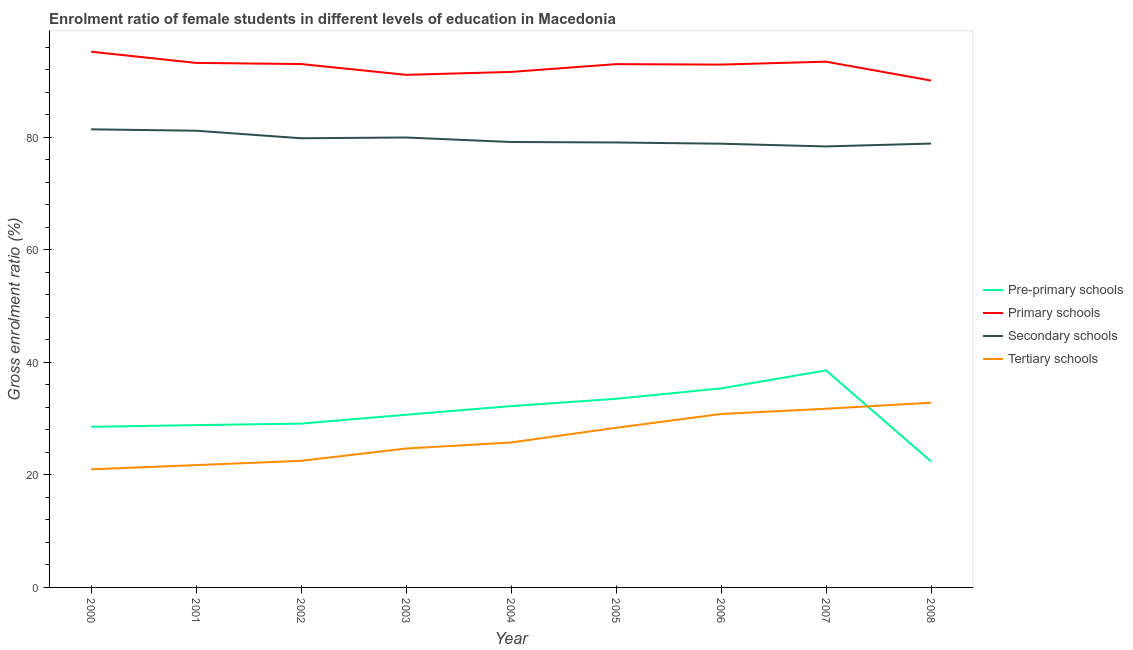How many different coloured lines are there?
Provide a succinct answer. 4. What is the gross enrolment ratio(male) in primary schools in 2003?
Provide a short and direct response. 91.11. Across all years, what is the maximum gross enrolment ratio(male) in pre-primary schools?
Keep it short and to the point. 38.58. Across all years, what is the minimum gross enrolment ratio(male) in primary schools?
Your answer should be very brief. 90.1. In which year was the gross enrolment ratio(male) in secondary schools maximum?
Provide a short and direct response. 2000. In which year was the gross enrolment ratio(male) in pre-primary schools minimum?
Make the answer very short. 2008. What is the total gross enrolment ratio(male) in primary schools in the graph?
Provide a short and direct response. 833.73. What is the difference between the gross enrolment ratio(male) in pre-primary schools in 2002 and that in 2004?
Ensure brevity in your answer.  -3.11. What is the difference between the gross enrolment ratio(male) in primary schools in 2002 and the gross enrolment ratio(male) in pre-primary schools in 2001?
Your response must be concise. 64.18. What is the average gross enrolment ratio(male) in primary schools per year?
Your answer should be very brief. 92.64. In the year 2001, what is the difference between the gross enrolment ratio(male) in tertiary schools and gross enrolment ratio(male) in pre-primary schools?
Ensure brevity in your answer.  -7.11. In how many years, is the gross enrolment ratio(male) in tertiary schools greater than 72 %?
Keep it short and to the point. 0. What is the ratio of the gross enrolment ratio(male) in secondary schools in 2000 to that in 2006?
Your response must be concise. 1.03. Is the gross enrolment ratio(male) in secondary schools in 2002 less than that in 2006?
Make the answer very short. No. What is the difference between the highest and the second highest gross enrolment ratio(male) in pre-primary schools?
Offer a very short reply. 3.2. What is the difference between the highest and the lowest gross enrolment ratio(male) in tertiary schools?
Your response must be concise. 11.84. In how many years, is the gross enrolment ratio(male) in tertiary schools greater than the average gross enrolment ratio(male) in tertiary schools taken over all years?
Your response must be concise. 4. Is the sum of the gross enrolment ratio(male) in pre-primary schools in 2001 and 2008 greater than the maximum gross enrolment ratio(male) in tertiary schools across all years?
Give a very brief answer. Yes. Is it the case that in every year, the sum of the gross enrolment ratio(male) in secondary schools and gross enrolment ratio(male) in pre-primary schools is greater than the sum of gross enrolment ratio(male) in tertiary schools and gross enrolment ratio(male) in primary schools?
Your answer should be very brief. Yes. Is it the case that in every year, the sum of the gross enrolment ratio(male) in pre-primary schools and gross enrolment ratio(male) in primary schools is greater than the gross enrolment ratio(male) in secondary schools?
Offer a very short reply. Yes. Is the gross enrolment ratio(male) in tertiary schools strictly greater than the gross enrolment ratio(male) in primary schools over the years?
Your answer should be compact. No. Is the gross enrolment ratio(male) in tertiary schools strictly less than the gross enrolment ratio(male) in pre-primary schools over the years?
Give a very brief answer. No. How many lines are there?
Your answer should be very brief. 4. How many years are there in the graph?
Provide a succinct answer. 9. How are the legend labels stacked?
Your answer should be compact. Vertical. What is the title of the graph?
Offer a very short reply. Enrolment ratio of female students in different levels of education in Macedonia. Does "Secondary" appear as one of the legend labels in the graph?
Give a very brief answer. No. What is the Gross enrolment ratio (%) in Pre-primary schools in 2000?
Give a very brief answer. 28.55. What is the Gross enrolment ratio (%) in Primary schools in 2000?
Your answer should be compact. 95.22. What is the Gross enrolment ratio (%) in Secondary schools in 2000?
Offer a very short reply. 81.43. What is the Gross enrolment ratio (%) of Tertiary schools in 2000?
Give a very brief answer. 21. What is the Gross enrolment ratio (%) of Pre-primary schools in 2001?
Give a very brief answer. 28.85. What is the Gross enrolment ratio (%) of Primary schools in 2001?
Offer a very short reply. 93.23. What is the Gross enrolment ratio (%) of Secondary schools in 2001?
Make the answer very short. 81.18. What is the Gross enrolment ratio (%) of Tertiary schools in 2001?
Keep it short and to the point. 21.74. What is the Gross enrolment ratio (%) of Pre-primary schools in 2002?
Give a very brief answer. 29.12. What is the Gross enrolment ratio (%) of Primary schools in 2002?
Offer a terse response. 93.03. What is the Gross enrolment ratio (%) of Secondary schools in 2002?
Provide a succinct answer. 79.84. What is the Gross enrolment ratio (%) of Tertiary schools in 2002?
Provide a succinct answer. 22.5. What is the Gross enrolment ratio (%) of Pre-primary schools in 2003?
Give a very brief answer. 30.7. What is the Gross enrolment ratio (%) of Primary schools in 2003?
Give a very brief answer. 91.11. What is the Gross enrolment ratio (%) in Secondary schools in 2003?
Ensure brevity in your answer.  79.97. What is the Gross enrolment ratio (%) of Tertiary schools in 2003?
Keep it short and to the point. 24.69. What is the Gross enrolment ratio (%) in Pre-primary schools in 2004?
Provide a short and direct response. 32.23. What is the Gross enrolment ratio (%) in Primary schools in 2004?
Offer a terse response. 91.63. What is the Gross enrolment ratio (%) in Secondary schools in 2004?
Make the answer very short. 79.17. What is the Gross enrolment ratio (%) of Tertiary schools in 2004?
Give a very brief answer. 25.76. What is the Gross enrolment ratio (%) in Pre-primary schools in 2005?
Keep it short and to the point. 33.53. What is the Gross enrolment ratio (%) of Primary schools in 2005?
Your response must be concise. 93.01. What is the Gross enrolment ratio (%) in Secondary schools in 2005?
Provide a short and direct response. 79.09. What is the Gross enrolment ratio (%) in Tertiary schools in 2005?
Keep it short and to the point. 28.38. What is the Gross enrolment ratio (%) of Pre-primary schools in 2006?
Your answer should be very brief. 35.38. What is the Gross enrolment ratio (%) of Primary schools in 2006?
Your answer should be compact. 92.93. What is the Gross enrolment ratio (%) of Secondary schools in 2006?
Ensure brevity in your answer.  78.87. What is the Gross enrolment ratio (%) in Tertiary schools in 2006?
Offer a terse response. 30.83. What is the Gross enrolment ratio (%) of Pre-primary schools in 2007?
Your response must be concise. 38.58. What is the Gross enrolment ratio (%) of Primary schools in 2007?
Offer a very short reply. 93.45. What is the Gross enrolment ratio (%) of Secondary schools in 2007?
Offer a terse response. 78.38. What is the Gross enrolment ratio (%) of Tertiary schools in 2007?
Provide a short and direct response. 31.76. What is the Gross enrolment ratio (%) of Pre-primary schools in 2008?
Give a very brief answer. 22.4. What is the Gross enrolment ratio (%) in Primary schools in 2008?
Ensure brevity in your answer.  90.1. What is the Gross enrolment ratio (%) in Secondary schools in 2008?
Your response must be concise. 78.9. What is the Gross enrolment ratio (%) in Tertiary schools in 2008?
Provide a short and direct response. 32.84. Across all years, what is the maximum Gross enrolment ratio (%) in Pre-primary schools?
Offer a very short reply. 38.58. Across all years, what is the maximum Gross enrolment ratio (%) in Primary schools?
Ensure brevity in your answer.  95.22. Across all years, what is the maximum Gross enrolment ratio (%) of Secondary schools?
Provide a succinct answer. 81.43. Across all years, what is the maximum Gross enrolment ratio (%) of Tertiary schools?
Your response must be concise. 32.84. Across all years, what is the minimum Gross enrolment ratio (%) of Pre-primary schools?
Provide a short and direct response. 22.4. Across all years, what is the minimum Gross enrolment ratio (%) of Primary schools?
Make the answer very short. 90.1. Across all years, what is the minimum Gross enrolment ratio (%) in Secondary schools?
Make the answer very short. 78.38. Across all years, what is the minimum Gross enrolment ratio (%) of Tertiary schools?
Your answer should be compact. 21. What is the total Gross enrolment ratio (%) of Pre-primary schools in the graph?
Your answer should be very brief. 279.34. What is the total Gross enrolment ratio (%) in Primary schools in the graph?
Provide a succinct answer. 833.73. What is the total Gross enrolment ratio (%) in Secondary schools in the graph?
Keep it short and to the point. 716.84. What is the total Gross enrolment ratio (%) in Tertiary schools in the graph?
Your answer should be very brief. 239.5. What is the difference between the Gross enrolment ratio (%) of Pre-primary schools in 2000 and that in 2001?
Your answer should be very brief. -0.3. What is the difference between the Gross enrolment ratio (%) in Primary schools in 2000 and that in 2001?
Provide a succinct answer. 1.99. What is the difference between the Gross enrolment ratio (%) in Secondary schools in 2000 and that in 2001?
Ensure brevity in your answer.  0.25. What is the difference between the Gross enrolment ratio (%) of Tertiary schools in 2000 and that in 2001?
Offer a terse response. -0.75. What is the difference between the Gross enrolment ratio (%) in Pre-primary schools in 2000 and that in 2002?
Offer a very short reply. -0.57. What is the difference between the Gross enrolment ratio (%) of Primary schools in 2000 and that in 2002?
Keep it short and to the point. 2.19. What is the difference between the Gross enrolment ratio (%) in Secondary schools in 2000 and that in 2002?
Ensure brevity in your answer.  1.59. What is the difference between the Gross enrolment ratio (%) of Tertiary schools in 2000 and that in 2002?
Offer a very short reply. -1.51. What is the difference between the Gross enrolment ratio (%) in Pre-primary schools in 2000 and that in 2003?
Keep it short and to the point. -2.15. What is the difference between the Gross enrolment ratio (%) of Primary schools in 2000 and that in 2003?
Offer a terse response. 4.11. What is the difference between the Gross enrolment ratio (%) of Secondary schools in 2000 and that in 2003?
Provide a succinct answer. 1.45. What is the difference between the Gross enrolment ratio (%) of Tertiary schools in 2000 and that in 2003?
Provide a short and direct response. -3.69. What is the difference between the Gross enrolment ratio (%) of Pre-primary schools in 2000 and that in 2004?
Offer a terse response. -3.68. What is the difference between the Gross enrolment ratio (%) of Primary schools in 2000 and that in 2004?
Provide a succinct answer. 3.59. What is the difference between the Gross enrolment ratio (%) in Secondary schools in 2000 and that in 2004?
Provide a succinct answer. 2.25. What is the difference between the Gross enrolment ratio (%) in Tertiary schools in 2000 and that in 2004?
Give a very brief answer. -4.76. What is the difference between the Gross enrolment ratio (%) in Pre-primary schools in 2000 and that in 2005?
Ensure brevity in your answer.  -4.98. What is the difference between the Gross enrolment ratio (%) of Primary schools in 2000 and that in 2005?
Your answer should be very brief. 2.21. What is the difference between the Gross enrolment ratio (%) in Secondary schools in 2000 and that in 2005?
Provide a short and direct response. 2.34. What is the difference between the Gross enrolment ratio (%) in Tertiary schools in 2000 and that in 2005?
Provide a succinct answer. -7.38. What is the difference between the Gross enrolment ratio (%) of Pre-primary schools in 2000 and that in 2006?
Provide a short and direct response. -6.83. What is the difference between the Gross enrolment ratio (%) of Primary schools in 2000 and that in 2006?
Ensure brevity in your answer.  2.29. What is the difference between the Gross enrolment ratio (%) in Secondary schools in 2000 and that in 2006?
Offer a terse response. 2.56. What is the difference between the Gross enrolment ratio (%) of Tertiary schools in 2000 and that in 2006?
Give a very brief answer. -9.83. What is the difference between the Gross enrolment ratio (%) in Pre-primary schools in 2000 and that in 2007?
Your response must be concise. -10.03. What is the difference between the Gross enrolment ratio (%) in Primary schools in 2000 and that in 2007?
Keep it short and to the point. 1.77. What is the difference between the Gross enrolment ratio (%) in Secondary schools in 2000 and that in 2007?
Provide a succinct answer. 3.04. What is the difference between the Gross enrolment ratio (%) in Tertiary schools in 2000 and that in 2007?
Your answer should be compact. -10.76. What is the difference between the Gross enrolment ratio (%) in Pre-primary schools in 2000 and that in 2008?
Give a very brief answer. 6.15. What is the difference between the Gross enrolment ratio (%) of Primary schools in 2000 and that in 2008?
Make the answer very short. 5.13. What is the difference between the Gross enrolment ratio (%) of Secondary schools in 2000 and that in 2008?
Offer a very short reply. 2.53. What is the difference between the Gross enrolment ratio (%) of Tertiary schools in 2000 and that in 2008?
Offer a very short reply. -11.84. What is the difference between the Gross enrolment ratio (%) in Pre-primary schools in 2001 and that in 2002?
Your answer should be compact. -0.27. What is the difference between the Gross enrolment ratio (%) of Primary schools in 2001 and that in 2002?
Offer a very short reply. 0.2. What is the difference between the Gross enrolment ratio (%) of Secondary schools in 2001 and that in 2002?
Provide a short and direct response. 1.34. What is the difference between the Gross enrolment ratio (%) in Tertiary schools in 2001 and that in 2002?
Your answer should be compact. -0.76. What is the difference between the Gross enrolment ratio (%) in Pre-primary schools in 2001 and that in 2003?
Offer a terse response. -1.84. What is the difference between the Gross enrolment ratio (%) of Primary schools in 2001 and that in 2003?
Your answer should be compact. 2.12. What is the difference between the Gross enrolment ratio (%) in Secondary schools in 2001 and that in 2003?
Your response must be concise. 1.21. What is the difference between the Gross enrolment ratio (%) in Tertiary schools in 2001 and that in 2003?
Keep it short and to the point. -2.95. What is the difference between the Gross enrolment ratio (%) of Pre-primary schools in 2001 and that in 2004?
Provide a succinct answer. -3.38. What is the difference between the Gross enrolment ratio (%) in Primary schools in 2001 and that in 2004?
Provide a succinct answer. 1.6. What is the difference between the Gross enrolment ratio (%) of Secondary schools in 2001 and that in 2004?
Make the answer very short. 2.01. What is the difference between the Gross enrolment ratio (%) of Tertiary schools in 2001 and that in 2004?
Make the answer very short. -4.02. What is the difference between the Gross enrolment ratio (%) in Pre-primary schools in 2001 and that in 2005?
Offer a terse response. -4.68. What is the difference between the Gross enrolment ratio (%) in Primary schools in 2001 and that in 2005?
Provide a short and direct response. 0.22. What is the difference between the Gross enrolment ratio (%) in Secondary schools in 2001 and that in 2005?
Your response must be concise. 2.09. What is the difference between the Gross enrolment ratio (%) in Tertiary schools in 2001 and that in 2005?
Offer a very short reply. -6.64. What is the difference between the Gross enrolment ratio (%) of Pre-primary schools in 2001 and that in 2006?
Your answer should be very brief. -6.53. What is the difference between the Gross enrolment ratio (%) of Primary schools in 2001 and that in 2006?
Offer a very short reply. 0.3. What is the difference between the Gross enrolment ratio (%) in Secondary schools in 2001 and that in 2006?
Make the answer very short. 2.31. What is the difference between the Gross enrolment ratio (%) in Tertiary schools in 2001 and that in 2006?
Your answer should be very brief. -9.09. What is the difference between the Gross enrolment ratio (%) in Pre-primary schools in 2001 and that in 2007?
Provide a succinct answer. -9.73. What is the difference between the Gross enrolment ratio (%) in Primary schools in 2001 and that in 2007?
Make the answer very short. -0.22. What is the difference between the Gross enrolment ratio (%) of Secondary schools in 2001 and that in 2007?
Offer a very short reply. 2.8. What is the difference between the Gross enrolment ratio (%) in Tertiary schools in 2001 and that in 2007?
Make the answer very short. -10.02. What is the difference between the Gross enrolment ratio (%) in Pre-primary schools in 2001 and that in 2008?
Keep it short and to the point. 6.45. What is the difference between the Gross enrolment ratio (%) of Primary schools in 2001 and that in 2008?
Provide a succinct answer. 3.14. What is the difference between the Gross enrolment ratio (%) of Secondary schools in 2001 and that in 2008?
Provide a short and direct response. 2.28. What is the difference between the Gross enrolment ratio (%) in Tertiary schools in 2001 and that in 2008?
Provide a short and direct response. -11.09. What is the difference between the Gross enrolment ratio (%) in Pre-primary schools in 2002 and that in 2003?
Ensure brevity in your answer.  -1.58. What is the difference between the Gross enrolment ratio (%) of Primary schools in 2002 and that in 2003?
Offer a terse response. 1.92. What is the difference between the Gross enrolment ratio (%) of Secondary schools in 2002 and that in 2003?
Make the answer very short. -0.13. What is the difference between the Gross enrolment ratio (%) of Tertiary schools in 2002 and that in 2003?
Ensure brevity in your answer.  -2.19. What is the difference between the Gross enrolment ratio (%) in Pre-primary schools in 2002 and that in 2004?
Your answer should be compact. -3.11. What is the difference between the Gross enrolment ratio (%) of Primary schools in 2002 and that in 2004?
Make the answer very short. 1.4. What is the difference between the Gross enrolment ratio (%) in Secondary schools in 2002 and that in 2004?
Make the answer very short. 0.67. What is the difference between the Gross enrolment ratio (%) of Tertiary schools in 2002 and that in 2004?
Ensure brevity in your answer.  -3.26. What is the difference between the Gross enrolment ratio (%) of Pre-primary schools in 2002 and that in 2005?
Your answer should be compact. -4.41. What is the difference between the Gross enrolment ratio (%) of Primary schools in 2002 and that in 2005?
Offer a very short reply. 0.02. What is the difference between the Gross enrolment ratio (%) in Secondary schools in 2002 and that in 2005?
Provide a short and direct response. 0.75. What is the difference between the Gross enrolment ratio (%) in Tertiary schools in 2002 and that in 2005?
Ensure brevity in your answer.  -5.88. What is the difference between the Gross enrolment ratio (%) in Pre-primary schools in 2002 and that in 2006?
Give a very brief answer. -6.26. What is the difference between the Gross enrolment ratio (%) in Primary schools in 2002 and that in 2006?
Keep it short and to the point. 0.1. What is the difference between the Gross enrolment ratio (%) of Secondary schools in 2002 and that in 2006?
Make the answer very short. 0.97. What is the difference between the Gross enrolment ratio (%) in Tertiary schools in 2002 and that in 2006?
Ensure brevity in your answer.  -8.33. What is the difference between the Gross enrolment ratio (%) in Pre-primary schools in 2002 and that in 2007?
Your answer should be compact. -9.46. What is the difference between the Gross enrolment ratio (%) of Primary schools in 2002 and that in 2007?
Offer a terse response. -0.42. What is the difference between the Gross enrolment ratio (%) in Secondary schools in 2002 and that in 2007?
Your response must be concise. 1.46. What is the difference between the Gross enrolment ratio (%) of Tertiary schools in 2002 and that in 2007?
Offer a terse response. -9.26. What is the difference between the Gross enrolment ratio (%) of Pre-primary schools in 2002 and that in 2008?
Offer a terse response. 6.72. What is the difference between the Gross enrolment ratio (%) in Primary schools in 2002 and that in 2008?
Give a very brief answer. 2.93. What is the difference between the Gross enrolment ratio (%) in Secondary schools in 2002 and that in 2008?
Ensure brevity in your answer.  0.94. What is the difference between the Gross enrolment ratio (%) in Tertiary schools in 2002 and that in 2008?
Your answer should be very brief. -10.33. What is the difference between the Gross enrolment ratio (%) of Pre-primary schools in 2003 and that in 2004?
Your response must be concise. -1.53. What is the difference between the Gross enrolment ratio (%) of Primary schools in 2003 and that in 2004?
Give a very brief answer. -0.52. What is the difference between the Gross enrolment ratio (%) in Secondary schools in 2003 and that in 2004?
Ensure brevity in your answer.  0.8. What is the difference between the Gross enrolment ratio (%) of Tertiary schools in 2003 and that in 2004?
Give a very brief answer. -1.07. What is the difference between the Gross enrolment ratio (%) of Pre-primary schools in 2003 and that in 2005?
Offer a very short reply. -2.83. What is the difference between the Gross enrolment ratio (%) of Primary schools in 2003 and that in 2005?
Your response must be concise. -1.9. What is the difference between the Gross enrolment ratio (%) of Secondary schools in 2003 and that in 2005?
Ensure brevity in your answer.  0.89. What is the difference between the Gross enrolment ratio (%) of Tertiary schools in 2003 and that in 2005?
Keep it short and to the point. -3.69. What is the difference between the Gross enrolment ratio (%) of Pre-primary schools in 2003 and that in 2006?
Ensure brevity in your answer.  -4.69. What is the difference between the Gross enrolment ratio (%) in Primary schools in 2003 and that in 2006?
Keep it short and to the point. -1.82. What is the difference between the Gross enrolment ratio (%) in Secondary schools in 2003 and that in 2006?
Provide a short and direct response. 1.1. What is the difference between the Gross enrolment ratio (%) of Tertiary schools in 2003 and that in 2006?
Offer a very short reply. -6.14. What is the difference between the Gross enrolment ratio (%) in Pre-primary schools in 2003 and that in 2007?
Give a very brief answer. -7.88. What is the difference between the Gross enrolment ratio (%) of Primary schools in 2003 and that in 2007?
Your answer should be very brief. -2.34. What is the difference between the Gross enrolment ratio (%) of Secondary schools in 2003 and that in 2007?
Provide a succinct answer. 1.59. What is the difference between the Gross enrolment ratio (%) in Tertiary schools in 2003 and that in 2007?
Keep it short and to the point. -7.07. What is the difference between the Gross enrolment ratio (%) in Pre-primary schools in 2003 and that in 2008?
Your answer should be compact. 8.29. What is the difference between the Gross enrolment ratio (%) of Primary schools in 2003 and that in 2008?
Make the answer very short. 1.02. What is the difference between the Gross enrolment ratio (%) of Secondary schools in 2003 and that in 2008?
Give a very brief answer. 1.08. What is the difference between the Gross enrolment ratio (%) in Tertiary schools in 2003 and that in 2008?
Provide a succinct answer. -8.15. What is the difference between the Gross enrolment ratio (%) in Pre-primary schools in 2004 and that in 2005?
Offer a very short reply. -1.3. What is the difference between the Gross enrolment ratio (%) in Primary schools in 2004 and that in 2005?
Your answer should be compact. -1.38. What is the difference between the Gross enrolment ratio (%) of Secondary schools in 2004 and that in 2005?
Offer a terse response. 0.08. What is the difference between the Gross enrolment ratio (%) in Tertiary schools in 2004 and that in 2005?
Provide a short and direct response. -2.62. What is the difference between the Gross enrolment ratio (%) in Pre-primary schools in 2004 and that in 2006?
Provide a succinct answer. -3.15. What is the difference between the Gross enrolment ratio (%) in Primary schools in 2004 and that in 2006?
Provide a succinct answer. -1.3. What is the difference between the Gross enrolment ratio (%) of Secondary schools in 2004 and that in 2006?
Your response must be concise. 0.3. What is the difference between the Gross enrolment ratio (%) in Tertiary schools in 2004 and that in 2006?
Provide a succinct answer. -5.07. What is the difference between the Gross enrolment ratio (%) in Pre-primary schools in 2004 and that in 2007?
Offer a terse response. -6.35. What is the difference between the Gross enrolment ratio (%) in Primary schools in 2004 and that in 2007?
Offer a very short reply. -1.82. What is the difference between the Gross enrolment ratio (%) of Secondary schools in 2004 and that in 2007?
Make the answer very short. 0.79. What is the difference between the Gross enrolment ratio (%) in Tertiary schools in 2004 and that in 2007?
Ensure brevity in your answer.  -6. What is the difference between the Gross enrolment ratio (%) of Pre-primary schools in 2004 and that in 2008?
Your answer should be very brief. 9.83. What is the difference between the Gross enrolment ratio (%) of Primary schools in 2004 and that in 2008?
Your answer should be compact. 1.53. What is the difference between the Gross enrolment ratio (%) in Secondary schools in 2004 and that in 2008?
Provide a short and direct response. 0.27. What is the difference between the Gross enrolment ratio (%) of Tertiary schools in 2004 and that in 2008?
Your response must be concise. -7.07. What is the difference between the Gross enrolment ratio (%) of Pre-primary schools in 2005 and that in 2006?
Offer a very short reply. -1.85. What is the difference between the Gross enrolment ratio (%) in Primary schools in 2005 and that in 2006?
Provide a short and direct response. 0.08. What is the difference between the Gross enrolment ratio (%) in Secondary schools in 2005 and that in 2006?
Your answer should be compact. 0.22. What is the difference between the Gross enrolment ratio (%) in Tertiary schools in 2005 and that in 2006?
Give a very brief answer. -2.45. What is the difference between the Gross enrolment ratio (%) of Pre-primary schools in 2005 and that in 2007?
Your answer should be very brief. -5.05. What is the difference between the Gross enrolment ratio (%) of Primary schools in 2005 and that in 2007?
Give a very brief answer. -0.44. What is the difference between the Gross enrolment ratio (%) of Secondary schools in 2005 and that in 2007?
Your answer should be very brief. 0.7. What is the difference between the Gross enrolment ratio (%) of Tertiary schools in 2005 and that in 2007?
Provide a short and direct response. -3.38. What is the difference between the Gross enrolment ratio (%) of Pre-primary schools in 2005 and that in 2008?
Keep it short and to the point. 11.13. What is the difference between the Gross enrolment ratio (%) in Primary schools in 2005 and that in 2008?
Provide a short and direct response. 2.92. What is the difference between the Gross enrolment ratio (%) of Secondary schools in 2005 and that in 2008?
Offer a terse response. 0.19. What is the difference between the Gross enrolment ratio (%) of Tertiary schools in 2005 and that in 2008?
Provide a succinct answer. -4.46. What is the difference between the Gross enrolment ratio (%) of Pre-primary schools in 2006 and that in 2007?
Give a very brief answer. -3.2. What is the difference between the Gross enrolment ratio (%) in Primary schools in 2006 and that in 2007?
Your response must be concise. -0.52. What is the difference between the Gross enrolment ratio (%) of Secondary schools in 2006 and that in 2007?
Your answer should be very brief. 0.48. What is the difference between the Gross enrolment ratio (%) in Tertiary schools in 2006 and that in 2007?
Ensure brevity in your answer.  -0.93. What is the difference between the Gross enrolment ratio (%) of Pre-primary schools in 2006 and that in 2008?
Your answer should be compact. 12.98. What is the difference between the Gross enrolment ratio (%) of Primary schools in 2006 and that in 2008?
Provide a succinct answer. 2.84. What is the difference between the Gross enrolment ratio (%) in Secondary schools in 2006 and that in 2008?
Give a very brief answer. -0.03. What is the difference between the Gross enrolment ratio (%) of Tertiary schools in 2006 and that in 2008?
Give a very brief answer. -2.01. What is the difference between the Gross enrolment ratio (%) in Pre-primary schools in 2007 and that in 2008?
Provide a succinct answer. 16.18. What is the difference between the Gross enrolment ratio (%) of Primary schools in 2007 and that in 2008?
Give a very brief answer. 3.36. What is the difference between the Gross enrolment ratio (%) in Secondary schools in 2007 and that in 2008?
Give a very brief answer. -0.51. What is the difference between the Gross enrolment ratio (%) of Tertiary schools in 2007 and that in 2008?
Ensure brevity in your answer.  -1.08. What is the difference between the Gross enrolment ratio (%) of Pre-primary schools in 2000 and the Gross enrolment ratio (%) of Primary schools in 2001?
Provide a short and direct response. -64.68. What is the difference between the Gross enrolment ratio (%) in Pre-primary schools in 2000 and the Gross enrolment ratio (%) in Secondary schools in 2001?
Give a very brief answer. -52.63. What is the difference between the Gross enrolment ratio (%) in Pre-primary schools in 2000 and the Gross enrolment ratio (%) in Tertiary schools in 2001?
Give a very brief answer. 6.81. What is the difference between the Gross enrolment ratio (%) of Primary schools in 2000 and the Gross enrolment ratio (%) of Secondary schools in 2001?
Make the answer very short. 14.04. What is the difference between the Gross enrolment ratio (%) in Primary schools in 2000 and the Gross enrolment ratio (%) in Tertiary schools in 2001?
Provide a short and direct response. 73.48. What is the difference between the Gross enrolment ratio (%) of Secondary schools in 2000 and the Gross enrolment ratio (%) of Tertiary schools in 2001?
Offer a terse response. 59.68. What is the difference between the Gross enrolment ratio (%) in Pre-primary schools in 2000 and the Gross enrolment ratio (%) in Primary schools in 2002?
Your answer should be very brief. -64.48. What is the difference between the Gross enrolment ratio (%) in Pre-primary schools in 2000 and the Gross enrolment ratio (%) in Secondary schools in 2002?
Ensure brevity in your answer.  -51.29. What is the difference between the Gross enrolment ratio (%) of Pre-primary schools in 2000 and the Gross enrolment ratio (%) of Tertiary schools in 2002?
Give a very brief answer. 6.05. What is the difference between the Gross enrolment ratio (%) of Primary schools in 2000 and the Gross enrolment ratio (%) of Secondary schools in 2002?
Make the answer very short. 15.38. What is the difference between the Gross enrolment ratio (%) in Primary schools in 2000 and the Gross enrolment ratio (%) in Tertiary schools in 2002?
Your answer should be compact. 72.72. What is the difference between the Gross enrolment ratio (%) of Secondary schools in 2000 and the Gross enrolment ratio (%) of Tertiary schools in 2002?
Your answer should be compact. 58.92. What is the difference between the Gross enrolment ratio (%) in Pre-primary schools in 2000 and the Gross enrolment ratio (%) in Primary schools in 2003?
Your answer should be very brief. -62.56. What is the difference between the Gross enrolment ratio (%) in Pre-primary schools in 2000 and the Gross enrolment ratio (%) in Secondary schools in 2003?
Keep it short and to the point. -51.42. What is the difference between the Gross enrolment ratio (%) in Pre-primary schools in 2000 and the Gross enrolment ratio (%) in Tertiary schools in 2003?
Provide a succinct answer. 3.86. What is the difference between the Gross enrolment ratio (%) of Primary schools in 2000 and the Gross enrolment ratio (%) of Secondary schools in 2003?
Provide a short and direct response. 15.25. What is the difference between the Gross enrolment ratio (%) of Primary schools in 2000 and the Gross enrolment ratio (%) of Tertiary schools in 2003?
Offer a terse response. 70.53. What is the difference between the Gross enrolment ratio (%) in Secondary schools in 2000 and the Gross enrolment ratio (%) in Tertiary schools in 2003?
Your response must be concise. 56.74. What is the difference between the Gross enrolment ratio (%) of Pre-primary schools in 2000 and the Gross enrolment ratio (%) of Primary schools in 2004?
Offer a terse response. -63.08. What is the difference between the Gross enrolment ratio (%) of Pre-primary schools in 2000 and the Gross enrolment ratio (%) of Secondary schools in 2004?
Your answer should be compact. -50.62. What is the difference between the Gross enrolment ratio (%) of Pre-primary schools in 2000 and the Gross enrolment ratio (%) of Tertiary schools in 2004?
Keep it short and to the point. 2.79. What is the difference between the Gross enrolment ratio (%) in Primary schools in 2000 and the Gross enrolment ratio (%) in Secondary schools in 2004?
Provide a short and direct response. 16.05. What is the difference between the Gross enrolment ratio (%) of Primary schools in 2000 and the Gross enrolment ratio (%) of Tertiary schools in 2004?
Make the answer very short. 69.46. What is the difference between the Gross enrolment ratio (%) of Secondary schools in 2000 and the Gross enrolment ratio (%) of Tertiary schools in 2004?
Your answer should be compact. 55.66. What is the difference between the Gross enrolment ratio (%) in Pre-primary schools in 2000 and the Gross enrolment ratio (%) in Primary schools in 2005?
Your answer should be very brief. -64.46. What is the difference between the Gross enrolment ratio (%) in Pre-primary schools in 2000 and the Gross enrolment ratio (%) in Secondary schools in 2005?
Provide a short and direct response. -50.54. What is the difference between the Gross enrolment ratio (%) of Pre-primary schools in 2000 and the Gross enrolment ratio (%) of Tertiary schools in 2005?
Provide a short and direct response. 0.17. What is the difference between the Gross enrolment ratio (%) in Primary schools in 2000 and the Gross enrolment ratio (%) in Secondary schools in 2005?
Ensure brevity in your answer.  16.13. What is the difference between the Gross enrolment ratio (%) of Primary schools in 2000 and the Gross enrolment ratio (%) of Tertiary schools in 2005?
Provide a short and direct response. 66.85. What is the difference between the Gross enrolment ratio (%) of Secondary schools in 2000 and the Gross enrolment ratio (%) of Tertiary schools in 2005?
Your answer should be very brief. 53.05. What is the difference between the Gross enrolment ratio (%) in Pre-primary schools in 2000 and the Gross enrolment ratio (%) in Primary schools in 2006?
Provide a short and direct response. -64.38. What is the difference between the Gross enrolment ratio (%) in Pre-primary schools in 2000 and the Gross enrolment ratio (%) in Secondary schools in 2006?
Your answer should be very brief. -50.32. What is the difference between the Gross enrolment ratio (%) of Pre-primary schools in 2000 and the Gross enrolment ratio (%) of Tertiary schools in 2006?
Make the answer very short. -2.28. What is the difference between the Gross enrolment ratio (%) in Primary schools in 2000 and the Gross enrolment ratio (%) in Secondary schools in 2006?
Keep it short and to the point. 16.35. What is the difference between the Gross enrolment ratio (%) in Primary schools in 2000 and the Gross enrolment ratio (%) in Tertiary schools in 2006?
Provide a succinct answer. 64.4. What is the difference between the Gross enrolment ratio (%) in Secondary schools in 2000 and the Gross enrolment ratio (%) in Tertiary schools in 2006?
Your answer should be very brief. 50.6. What is the difference between the Gross enrolment ratio (%) of Pre-primary schools in 2000 and the Gross enrolment ratio (%) of Primary schools in 2007?
Offer a very short reply. -64.9. What is the difference between the Gross enrolment ratio (%) in Pre-primary schools in 2000 and the Gross enrolment ratio (%) in Secondary schools in 2007?
Provide a succinct answer. -49.84. What is the difference between the Gross enrolment ratio (%) in Pre-primary schools in 2000 and the Gross enrolment ratio (%) in Tertiary schools in 2007?
Give a very brief answer. -3.21. What is the difference between the Gross enrolment ratio (%) of Primary schools in 2000 and the Gross enrolment ratio (%) of Secondary schools in 2007?
Offer a terse response. 16.84. What is the difference between the Gross enrolment ratio (%) in Primary schools in 2000 and the Gross enrolment ratio (%) in Tertiary schools in 2007?
Your response must be concise. 63.46. What is the difference between the Gross enrolment ratio (%) in Secondary schools in 2000 and the Gross enrolment ratio (%) in Tertiary schools in 2007?
Ensure brevity in your answer.  49.67. What is the difference between the Gross enrolment ratio (%) in Pre-primary schools in 2000 and the Gross enrolment ratio (%) in Primary schools in 2008?
Offer a terse response. -61.55. What is the difference between the Gross enrolment ratio (%) in Pre-primary schools in 2000 and the Gross enrolment ratio (%) in Secondary schools in 2008?
Offer a terse response. -50.35. What is the difference between the Gross enrolment ratio (%) of Pre-primary schools in 2000 and the Gross enrolment ratio (%) of Tertiary schools in 2008?
Ensure brevity in your answer.  -4.29. What is the difference between the Gross enrolment ratio (%) of Primary schools in 2000 and the Gross enrolment ratio (%) of Secondary schools in 2008?
Offer a terse response. 16.33. What is the difference between the Gross enrolment ratio (%) in Primary schools in 2000 and the Gross enrolment ratio (%) in Tertiary schools in 2008?
Make the answer very short. 62.39. What is the difference between the Gross enrolment ratio (%) in Secondary schools in 2000 and the Gross enrolment ratio (%) in Tertiary schools in 2008?
Ensure brevity in your answer.  48.59. What is the difference between the Gross enrolment ratio (%) in Pre-primary schools in 2001 and the Gross enrolment ratio (%) in Primary schools in 2002?
Give a very brief answer. -64.18. What is the difference between the Gross enrolment ratio (%) in Pre-primary schools in 2001 and the Gross enrolment ratio (%) in Secondary schools in 2002?
Give a very brief answer. -50.99. What is the difference between the Gross enrolment ratio (%) of Pre-primary schools in 2001 and the Gross enrolment ratio (%) of Tertiary schools in 2002?
Provide a succinct answer. 6.35. What is the difference between the Gross enrolment ratio (%) of Primary schools in 2001 and the Gross enrolment ratio (%) of Secondary schools in 2002?
Offer a very short reply. 13.39. What is the difference between the Gross enrolment ratio (%) of Primary schools in 2001 and the Gross enrolment ratio (%) of Tertiary schools in 2002?
Ensure brevity in your answer.  70.73. What is the difference between the Gross enrolment ratio (%) of Secondary schools in 2001 and the Gross enrolment ratio (%) of Tertiary schools in 2002?
Give a very brief answer. 58.68. What is the difference between the Gross enrolment ratio (%) in Pre-primary schools in 2001 and the Gross enrolment ratio (%) in Primary schools in 2003?
Offer a very short reply. -62.26. What is the difference between the Gross enrolment ratio (%) of Pre-primary schools in 2001 and the Gross enrolment ratio (%) of Secondary schools in 2003?
Keep it short and to the point. -51.12. What is the difference between the Gross enrolment ratio (%) of Pre-primary schools in 2001 and the Gross enrolment ratio (%) of Tertiary schools in 2003?
Your answer should be very brief. 4.16. What is the difference between the Gross enrolment ratio (%) in Primary schools in 2001 and the Gross enrolment ratio (%) in Secondary schools in 2003?
Provide a short and direct response. 13.26. What is the difference between the Gross enrolment ratio (%) in Primary schools in 2001 and the Gross enrolment ratio (%) in Tertiary schools in 2003?
Provide a succinct answer. 68.54. What is the difference between the Gross enrolment ratio (%) in Secondary schools in 2001 and the Gross enrolment ratio (%) in Tertiary schools in 2003?
Give a very brief answer. 56.49. What is the difference between the Gross enrolment ratio (%) in Pre-primary schools in 2001 and the Gross enrolment ratio (%) in Primary schools in 2004?
Provide a short and direct response. -62.78. What is the difference between the Gross enrolment ratio (%) of Pre-primary schools in 2001 and the Gross enrolment ratio (%) of Secondary schools in 2004?
Your answer should be very brief. -50.32. What is the difference between the Gross enrolment ratio (%) in Pre-primary schools in 2001 and the Gross enrolment ratio (%) in Tertiary schools in 2004?
Give a very brief answer. 3.09. What is the difference between the Gross enrolment ratio (%) of Primary schools in 2001 and the Gross enrolment ratio (%) of Secondary schools in 2004?
Provide a short and direct response. 14.06. What is the difference between the Gross enrolment ratio (%) of Primary schools in 2001 and the Gross enrolment ratio (%) of Tertiary schools in 2004?
Offer a terse response. 67.47. What is the difference between the Gross enrolment ratio (%) of Secondary schools in 2001 and the Gross enrolment ratio (%) of Tertiary schools in 2004?
Make the answer very short. 55.42. What is the difference between the Gross enrolment ratio (%) of Pre-primary schools in 2001 and the Gross enrolment ratio (%) of Primary schools in 2005?
Offer a very short reply. -64.16. What is the difference between the Gross enrolment ratio (%) in Pre-primary schools in 2001 and the Gross enrolment ratio (%) in Secondary schools in 2005?
Your answer should be compact. -50.24. What is the difference between the Gross enrolment ratio (%) in Pre-primary schools in 2001 and the Gross enrolment ratio (%) in Tertiary schools in 2005?
Provide a succinct answer. 0.47. What is the difference between the Gross enrolment ratio (%) in Primary schools in 2001 and the Gross enrolment ratio (%) in Secondary schools in 2005?
Ensure brevity in your answer.  14.14. What is the difference between the Gross enrolment ratio (%) of Primary schools in 2001 and the Gross enrolment ratio (%) of Tertiary schools in 2005?
Provide a succinct answer. 64.85. What is the difference between the Gross enrolment ratio (%) of Secondary schools in 2001 and the Gross enrolment ratio (%) of Tertiary schools in 2005?
Make the answer very short. 52.8. What is the difference between the Gross enrolment ratio (%) of Pre-primary schools in 2001 and the Gross enrolment ratio (%) of Primary schools in 2006?
Keep it short and to the point. -64.08. What is the difference between the Gross enrolment ratio (%) of Pre-primary schools in 2001 and the Gross enrolment ratio (%) of Secondary schools in 2006?
Give a very brief answer. -50.02. What is the difference between the Gross enrolment ratio (%) in Pre-primary schools in 2001 and the Gross enrolment ratio (%) in Tertiary schools in 2006?
Your answer should be compact. -1.98. What is the difference between the Gross enrolment ratio (%) of Primary schools in 2001 and the Gross enrolment ratio (%) of Secondary schools in 2006?
Offer a terse response. 14.36. What is the difference between the Gross enrolment ratio (%) in Primary schools in 2001 and the Gross enrolment ratio (%) in Tertiary schools in 2006?
Your answer should be compact. 62.4. What is the difference between the Gross enrolment ratio (%) in Secondary schools in 2001 and the Gross enrolment ratio (%) in Tertiary schools in 2006?
Keep it short and to the point. 50.35. What is the difference between the Gross enrolment ratio (%) of Pre-primary schools in 2001 and the Gross enrolment ratio (%) of Primary schools in 2007?
Keep it short and to the point. -64.6. What is the difference between the Gross enrolment ratio (%) of Pre-primary schools in 2001 and the Gross enrolment ratio (%) of Secondary schools in 2007?
Your answer should be compact. -49.53. What is the difference between the Gross enrolment ratio (%) of Pre-primary schools in 2001 and the Gross enrolment ratio (%) of Tertiary schools in 2007?
Provide a succinct answer. -2.91. What is the difference between the Gross enrolment ratio (%) of Primary schools in 2001 and the Gross enrolment ratio (%) of Secondary schools in 2007?
Make the answer very short. 14.85. What is the difference between the Gross enrolment ratio (%) of Primary schools in 2001 and the Gross enrolment ratio (%) of Tertiary schools in 2007?
Your answer should be compact. 61.47. What is the difference between the Gross enrolment ratio (%) in Secondary schools in 2001 and the Gross enrolment ratio (%) in Tertiary schools in 2007?
Offer a terse response. 49.42. What is the difference between the Gross enrolment ratio (%) in Pre-primary schools in 2001 and the Gross enrolment ratio (%) in Primary schools in 2008?
Ensure brevity in your answer.  -61.24. What is the difference between the Gross enrolment ratio (%) of Pre-primary schools in 2001 and the Gross enrolment ratio (%) of Secondary schools in 2008?
Ensure brevity in your answer.  -50.05. What is the difference between the Gross enrolment ratio (%) in Pre-primary schools in 2001 and the Gross enrolment ratio (%) in Tertiary schools in 2008?
Offer a very short reply. -3.98. What is the difference between the Gross enrolment ratio (%) in Primary schools in 2001 and the Gross enrolment ratio (%) in Secondary schools in 2008?
Give a very brief answer. 14.33. What is the difference between the Gross enrolment ratio (%) of Primary schools in 2001 and the Gross enrolment ratio (%) of Tertiary schools in 2008?
Make the answer very short. 60.4. What is the difference between the Gross enrolment ratio (%) in Secondary schools in 2001 and the Gross enrolment ratio (%) in Tertiary schools in 2008?
Offer a terse response. 48.34. What is the difference between the Gross enrolment ratio (%) of Pre-primary schools in 2002 and the Gross enrolment ratio (%) of Primary schools in 2003?
Offer a terse response. -61.99. What is the difference between the Gross enrolment ratio (%) of Pre-primary schools in 2002 and the Gross enrolment ratio (%) of Secondary schools in 2003?
Provide a short and direct response. -50.86. What is the difference between the Gross enrolment ratio (%) in Pre-primary schools in 2002 and the Gross enrolment ratio (%) in Tertiary schools in 2003?
Provide a succinct answer. 4.43. What is the difference between the Gross enrolment ratio (%) in Primary schools in 2002 and the Gross enrolment ratio (%) in Secondary schools in 2003?
Provide a succinct answer. 13.06. What is the difference between the Gross enrolment ratio (%) of Primary schools in 2002 and the Gross enrolment ratio (%) of Tertiary schools in 2003?
Offer a very short reply. 68.34. What is the difference between the Gross enrolment ratio (%) in Secondary schools in 2002 and the Gross enrolment ratio (%) in Tertiary schools in 2003?
Provide a succinct answer. 55.15. What is the difference between the Gross enrolment ratio (%) of Pre-primary schools in 2002 and the Gross enrolment ratio (%) of Primary schools in 2004?
Your answer should be compact. -62.51. What is the difference between the Gross enrolment ratio (%) in Pre-primary schools in 2002 and the Gross enrolment ratio (%) in Secondary schools in 2004?
Ensure brevity in your answer.  -50.05. What is the difference between the Gross enrolment ratio (%) in Pre-primary schools in 2002 and the Gross enrolment ratio (%) in Tertiary schools in 2004?
Give a very brief answer. 3.36. What is the difference between the Gross enrolment ratio (%) of Primary schools in 2002 and the Gross enrolment ratio (%) of Secondary schools in 2004?
Your response must be concise. 13.86. What is the difference between the Gross enrolment ratio (%) in Primary schools in 2002 and the Gross enrolment ratio (%) in Tertiary schools in 2004?
Provide a short and direct response. 67.27. What is the difference between the Gross enrolment ratio (%) in Secondary schools in 2002 and the Gross enrolment ratio (%) in Tertiary schools in 2004?
Your response must be concise. 54.08. What is the difference between the Gross enrolment ratio (%) in Pre-primary schools in 2002 and the Gross enrolment ratio (%) in Primary schools in 2005?
Provide a succinct answer. -63.89. What is the difference between the Gross enrolment ratio (%) in Pre-primary schools in 2002 and the Gross enrolment ratio (%) in Secondary schools in 2005?
Your answer should be compact. -49.97. What is the difference between the Gross enrolment ratio (%) in Pre-primary schools in 2002 and the Gross enrolment ratio (%) in Tertiary schools in 2005?
Your answer should be very brief. 0.74. What is the difference between the Gross enrolment ratio (%) of Primary schools in 2002 and the Gross enrolment ratio (%) of Secondary schools in 2005?
Make the answer very short. 13.94. What is the difference between the Gross enrolment ratio (%) in Primary schools in 2002 and the Gross enrolment ratio (%) in Tertiary schools in 2005?
Give a very brief answer. 64.65. What is the difference between the Gross enrolment ratio (%) in Secondary schools in 2002 and the Gross enrolment ratio (%) in Tertiary schools in 2005?
Make the answer very short. 51.46. What is the difference between the Gross enrolment ratio (%) of Pre-primary schools in 2002 and the Gross enrolment ratio (%) of Primary schools in 2006?
Your answer should be very brief. -63.81. What is the difference between the Gross enrolment ratio (%) in Pre-primary schools in 2002 and the Gross enrolment ratio (%) in Secondary schools in 2006?
Your answer should be very brief. -49.75. What is the difference between the Gross enrolment ratio (%) in Pre-primary schools in 2002 and the Gross enrolment ratio (%) in Tertiary schools in 2006?
Keep it short and to the point. -1.71. What is the difference between the Gross enrolment ratio (%) of Primary schools in 2002 and the Gross enrolment ratio (%) of Secondary schools in 2006?
Provide a succinct answer. 14.16. What is the difference between the Gross enrolment ratio (%) of Primary schools in 2002 and the Gross enrolment ratio (%) of Tertiary schools in 2006?
Your answer should be very brief. 62.2. What is the difference between the Gross enrolment ratio (%) of Secondary schools in 2002 and the Gross enrolment ratio (%) of Tertiary schools in 2006?
Your answer should be compact. 49.01. What is the difference between the Gross enrolment ratio (%) of Pre-primary schools in 2002 and the Gross enrolment ratio (%) of Primary schools in 2007?
Provide a short and direct response. -64.33. What is the difference between the Gross enrolment ratio (%) of Pre-primary schools in 2002 and the Gross enrolment ratio (%) of Secondary schools in 2007?
Make the answer very short. -49.27. What is the difference between the Gross enrolment ratio (%) in Pre-primary schools in 2002 and the Gross enrolment ratio (%) in Tertiary schools in 2007?
Give a very brief answer. -2.64. What is the difference between the Gross enrolment ratio (%) in Primary schools in 2002 and the Gross enrolment ratio (%) in Secondary schools in 2007?
Provide a succinct answer. 14.65. What is the difference between the Gross enrolment ratio (%) in Primary schools in 2002 and the Gross enrolment ratio (%) in Tertiary schools in 2007?
Make the answer very short. 61.27. What is the difference between the Gross enrolment ratio (%) of Secondary schools in 2002 and the Gross enrolment ratio (%) of Tertiary schools in 2007?
Give a very brief answer. 48.08. What is the difference between the Gross enrolment ratio (%) in Pre-primary schools in 2002 and the Gross enrolment ratio (%) in Primary schools in 2008?
Give a very brief answer. -60.98. What is the difference between the Gross enrolment ratio (%) of Pre-primary schools in 2002 and the Gross enrolment ratio (%) of Secondary schools in 2008?
Make the answer very short. -49.78. What is the difference between the Gross enrolment ratio (%) of Pre-primary schools in 2002 and the Gross enrolment ratio (%) of Tertiary schools in 2008?
Offer a terse response. -3.72. What is the difference between the Gross enrolment ratio (%) of Primary schools in 2002 and the Gross enrolment ratio (%) of Secondary schools in 2008?
Your response must be concise. 14.13. What is the difference between the Gross enrolment ratio (%) of Primary schools in 2002 and the Gross enrolment ratio (%) of Tertiary schools in 2008?
Give a very brief answer. 60.19. What is the difference between the Gross enrolment ratio (%) of Secondary schools in 2002 and the Gross enrolment ratio (%) of Tertiary schools in 2008?
Offer a very short reply. 47. What is the difference between the Gross enrolment ratio (%) in Pre-primary schools in 2003 and the Gross enrolment ratio (%) in Primary schools in 2004?
Give a very brief answer. -60.94. What is the difference between the Gross enrolment ratio (%) in Pre-primary schools in 2003 and the Gross enrolment ratio (%) in Secondary schools in 2004?
Your response must be concise. -48.48. What is the difference between the Gross enrolment ratio (%) of Pre-primary schools in 2003 and the Gross enrolment ratio (%) of Tertiary schools in 2004?
Make the answer very short. 4.93. What is the difference between the Gross enrolment ratio (%) in Primary schools in 2003 and the Gross enrolment ratio (%) in Secondary schools in 2004?
Ensure brevity in your answer.  11.94. What is the difference between the Gross enrolment ratio (%) of Primary schools in 2003 and the Gross enrolment ratio (%) of Tertiary schools in 2004?
Provide a succinct answer. 65.35. What is the difference between the Gross enrolment ratio (%) of Secondary schools in 2003 and the Gross enrolment ratio (%) of Tertiary schools in 2004?
Your answer should be compact. 54.21. What is the difference between the Gross enrolment ratio (%) in Pre-primary schools in 2003 and the Gross enrolment ratio (%) in Primary schools in 2005?
Ensure brevity in your answer.  -62.32. What is the difference between the Gross enrolment ratio (%) in Pre-primary schools in 2003 and the Gross enrolment ratio (%) in Secondary schools in 2005?
Your answer should be very brief. -48.39. What is the difference between the Gross enrolment ratio (%) in Pre-primary schools in 2003 and the Gross enrolment ratio (%) in Tertiary schools in 2005?
Offer a very short reply. 2.32. What is the difference between the Gross enrolment ratio (%) in Primary schools in 2003 and the Gross enrolment ratio (%) in Secondary schools in 2005?
Your answer should be compact. 12.02. What is the difference between the Gross enrolment ratio (%) in Primary schools in 2003 and the Gross enrolment ratio (%) in Tertiary schools in 2005?
Your response must be concise. 62.73. What is the difference between the Gross enrolment ratio (%) of Secondary schools in 2003 and the Gross enrolment ratio (%) of Tertiary schools in 2005?
Your response must be concise. 51.6. What is the difference between the Gross enrolment ratio (%) in Pre-primary schools in 2003 and the Gross enrolment ratio (%) in Primary schools in 2006?
Your answer should be compact. -62.24. What is the difference between the Gross enrolment ratio (%) of Pre-primary schools in 2003 and the Gross enrolment ratio (%) of Secondary schools in 2006?
Provide a succinct answer. -48.17. What is the difference between the Gross enrolment ratio (%) in Pre-primary schools in 2003 and the Gross enrolment ratio (%) in Tertiary schools in 2006?
Ensure brevity in your answer.  -0.13. What is the difference between the Gross enrolment ratio (%) of Primary schools in 2003 and the Gross enrolment ratio (%) of Secondary schools in 2006?
Make the answer very short. 12.24. What is the difference between the Gross enrolment ratio (%) in Primary schools in 2003 and the Gross enrolment ratio (%) in Tertiary schools in 2006?
Your response must be concise. 60.28. What is the difference between the Gross enrolment ratio (%) in Secondary schools in 2003 and the Gross enrolment ratio (%) in Tertiary schools in 2006?
Make the answer very short. 49.15. What is the difference between the Gross enrolment ratio (%) of Pre-primary schools in 2003 and the Gross enrolment ratio (%) of Primary schools in 2007?
Ensure brevity in your answer.  -62.76. What is the difference between the Gross enrolment ratio (%) in Pre-primary schools in 2003 and the Gross enrolment ratio (%) in Secondary schools in 2007?
Make the answer very short. -47.69. What is the difference between the Gross enrolment ratio (%) in Pre-primary schools in 2003 and the Gross enrolment ratio (%) in Tertiary schools in 2007?
Give a very brief answer. -1.06. What is the difference between the Gross enrolment ratio (%) in Primary schools in 2003 and the Gross enrolment ratio (%) in Secondary schools in 2007?
Ensure brevity in your answer.  12.73. What is the difference between the Gross enrolment ratio (%) in Primary schools in 2003 and the Gross enrolment ratio (%) in Tertiary schools in 2007?
Ensure brevity in your answer.  59.35. What is the difference between the Gross enrolment ratio (%) in Secondary schools in 2003 and the Gross enrolment ratio (%) in Tertiary schools in 2007?
Provide a short and direct response. 48.22. What is the difference between the Gross enrolment ratio (%) of Pre-primary schools in 2003 and the Gross enrolment ratio (%) of Primary schools in 2008?
Ensure brevity in your answer.  -59.4. What is the difference between the Gross enrolment ratio (%) in Pre-primary schools in 2003 and the Gross enrolment ratio (%) in Secondary schools in 2008?
Offer a terse response. -48.2. What is the difference between the Gross enrolment ratio (%) of Pre-primary schools in 2003 and the Gross enrolment ratio (%) of Tertiary schools in 2008?
Give a very brief answer. -2.14. What is the difference between the Gross enrolment ratio (%) of Primary schools in 2003 and the Gross enrolment ratio (%) of Secondary schools in 2008?
Provide a succinct answer. 12.21. What is the difference between the Gross enrolment ratio (%) of Primary schools in 2003 and the Gross enrolment ratio (%) of Tertiary schools in 2008?
Make the answer very short. 58.28. What is the difference between the Gross enrolment ratio (%) of Secondary schools in 2003 and the Gross enrolment ratio (%) of Tertiary schools in 2008?
Ensure brevity in your answer.  47.14. What is the difference between the Gross enrolment ratio (%) of Pre-primary schools in 2004 and the Gross enrolment ratio (%) of Primary schools in 2005?
Keep it short and to the point. -60.78. What is the difference between the Gross enrolment ratio (%) in Pre-primary schools in 2004 and the Gross enrolment ratio (%) in Secondary schools in 2005?
Your response must be concise. -46.86. What is the difference between the Gross enrolment ratio (%) in Pre-primary schools in 2004 and the Gross enrolment ratio (%) in Tertiary schools in 2005?
Give a very brief answer. 3.85. What is the difference between the Gross enrolment ratio (%) of Primary schools in 2004 and the Gross enrolment ratio (%) of Secondary schools in 2005?
Ensure brevity in your answer.  12.54. What is the difference between the Gross enrolment ratio (%) in Primary schools in 2004 and the Gross enrolment ratio (%) in Tertiary schools in 2005?
Make the answer very short. 63.25. What is the difference between the Gross enrolment ratio (%) in Secondary schools in 2004 and the Gross enrolment ratio (%) in Tertiary schools in 2005?
Keep it short and to the point. 50.79. What is the difference between the Gross enrolment ratio (%) in Pre-primary schools in 2004 and the Gross enrolment ratio (%) in Primary schools in 2006?
Ensure brevity in your answer.  -60.7. What is the difference between the Gross enrolment ratio (%) in Pre-primary schools in 2004 and the Gross enrolment ratio (%) in Secondary schools in 2006?
Offer a very short reply. -46.64. What is the difference between the Gross enrolment ratio (%) of Pre-primary schools in 2004 and the Gross enrolment ratio (%) of Tertiary schools in 2006?
Your answer should be very brief. 1.4. What is the difference between the Gross enrolment ratio (%) in Primary schools in 2004 and the Gross enrolment ratio (%) in Secondary schools in 2006?
Provide a succinct answer. 12.76. What is the difference between the Gross enrolment ratio (%) of Primary schools in 2004 and the Gross enrolment ratio (%) of Tertiary schools in 2006?
Your answer should be compact. 60.8. What is the difference between the Gross enrolment ratio (%) of Secondary schools in 2004 and the Gross enrolment ratio (%) of Tertiary schools in 2006?
Your response must be concise. 48.34. What is the difference between the Gross enrolment ratio (%) in Pre-primary schools in 2004 and the Gross enrolment ratio (%) in Primary schools in 2007?
Make the answer very short. -61.22. What is the difference between the Gross enrolment ratio (%) of Pre-primary schools in 2004 and the Gross enrolment ratio (%) of Secondary schools in 2007?
Offer a very short reply. -46.16. What is the difference between the Gross enrolment ratio (%) in Pre-primary schools in 2004 and the Gross enrolment ratio (%) in Tertiary schools in 2007?
Your answer should be very brief. 0.47. What is the difference between the Gross enrolment ratio (%) of Primary schools in 2004 and the Gross enrolment ratio (%) of Secondary schools in 2007?
Give a very brief answer. 13.25. What is the difference between the Gross enrolment ratio (%) in Primary schools in 2004 and the Gross enrolment ratio (%) in Tertiary schools in 2007?
Your answer should be very brief. 59.87. What is the difference between the Gross enrolment ratio (%) in Secondary schools in 2004 and the Gross enrolment ratio (%) in Tertiary schools in 2007?
Give a very brief answer. 47.41. What is the difference between the Gross enrolment ratio (%) of Pre-primary schools in 2004 and the Gross enrolment ratio (%) of Primary schools in 2008?
Make the answer very short. -57.87. What is the difference between the Gross enrolment ratio (%) of Pre-primary schools in 2004 and the Gross enrolment ratio (%) of Secondary schools in 2008?
Offer a very short reply. -46.67. What is the difference between the Gross enrolment ratio (%) in Pre-primary schools in 2004 and the Gross enrolment ratio (%) in Tertiary schools in 2008?
Your response must be concise. -0.61. What is the difference between the Gross enrolment ratio (%) of Primary schools in 2004 and the Gross enrolment ratio (%) of Secondary schools in 2008?
Make the answer very short. 12.73. What is the difference between the Gross enrolment ratio (%) in Primary schools in 2004 and the Gross enrolment ratio (%) in Tertiary schools in 2008?
Your answer should be compact. 58.79. What is the difference between the Gross enrolment ratio (%) of Secondary schools in 2004 and the Gross enrolment ratio (%) of Tertiary schools in 2008?
Offer a very short reply. 46.34. What is the difference between the Gross enrolment ratio (%) in Pre-primary schools in 2005 and the Gross enrolment ratio (%) in Primary schools in 2006?
Your answer should be compact. -59.4. What is the difference between the Gross enrolment ratio (%) in Pre-primary schools in 2005 and the Gross enrolment ratio (%) in Secondary schools in 2006?
Provide a succinct answer. -45.34. What is the difference between the Gross enrolment ratio (%) in Pre-primary schools in 2005 and the Gross enrolment ratio (%) in Tertiary schools in 2006?
Offer a terse response. 2.7. What is the difference between the Gross enrolment ratio (%) in Primary schools in 2005 and the Gross enrolment ratio (%) in Secondary schools in 2006?
Ensure brevity in your answer.  14.14. What is the difference between the Gross enrolment ratio (%) in Primary schools in 2005 and the Gross enrolment ratio (%) in Tertiary schools in 2006?
Offer a terse response. 62.18. What is the difference between the Gross enrolment ratio (%) in Secondary schools in 2005 and the Gross enrolment ratio (%) in Tertiary schools in 2006?
Make the answer very short. 48.26. What is the difference between the Gross enrolment ratio (%) in Pre-primary schools in 2005 and the Gross enrolment ratio (%) in Primary schools in 2007?
Make the answer very short. -59.92. What is the difference between the Gross enrolment ratio (%) in Pre-primary schools in 2005 and the Gross enrolment ratio (%) in Secondary schools in 2007?
Ensure brevity in your answer.  -44.85. What is the difference between the Gross enrolment ratio (%) in Pre-primary schools in 2005 and the Gross enrolment ratio (%) in Tertiary schools in 2007?
Ensure brevity in your answer.  1.77. What is the difference between the Gross enrolment ratio (%) of Primary schools in 2005 and the Gross enrolment ratio (%) of Secondary schools in 2007?
Provide a short and direct response. 14.63. What is the difference between the Gross enrolment ratio (%) of Primary schools in 2005 and the Gross enrolment ratio (%) of Tertiary schools in 2007?
Make the answer very short. 61.25. What is the difference between the Gross enrolment ratio (%) in Secondary schools in 2005 and the Gross enrolment ratio (%) in Tertiary schools in 2007?
Ensure brevity in your answer.  47.33. What is the difference between the Gross enrolment ratio (%) in Pre-primary schools in 2005 and the Gross enrolment ratio (%) in Primary schools in 2008?
Keep it short and to the point. -56.57. What is the difference between the Gross enrolment ratio (%) of Pre-primary schools in 2005 and the Gross enrolment ratio (%) of Secondary schools in 2008?
Offer a terse response. -45.37. What is the difference between the Gross enrolment ratio (%) of Pre-primary schools in 2005 and the Gross enrolment ratio (%) of Tertiary schools in 2008?
Your answer should be very brief. 0.69. What is the difference between the Gross enrolment ratio (%) of Primary schools in 2005 and the Gross enrolment ratio (%) of Secondary schools in 2008?
Keep it short and to the point. 14.11. What is the difference between the Gross enrolment ratio (%) in Primary schools in 2005 and the Gross enrolment ratio (%) in Tertiary schools in 2008?
Your answer should be very brief. 60.18. What is the difference between the Gross enrolment ratio (%) in Secondary schools in 2005 and the Gross enrolment ratio (%) in Tertiary schools in 2008?
Offer a very short reply. 46.25. What is the difference between the Gross enrolment ratio (%) of Pre-primary schools in 2006 and the Gross enrolment ratio (%) of Primary schools in 2007?
Your answer should be very brief. -58.07. What is the difference between the Gross enrolment ratio (%) of Pre-primary schools in 2006 and the Gross enrolment ratio (%) of Secondary schools in 2007?
Ensure brevity in your answer.  -43. What is the difference between the Gross enrolment ratio (%) in Pre-primary schools in 2006 and the Gross enrolment ratio (%) in Tertiary schools in 2007?
Your answer should be very brief. 3.62. What is the difference between the Gross enrolment ratio (%) in Primary schools in 2006 and the Gross enrolment ratio (%) in Secondary schools in 2007?
Ensure brevity in your answer.  14.55. What is the difference between the Gross enrolment ratio (%) in Primary schools in 2006 and the Gross enrolment ratio (%) in Tertiary schools in 2007?
Provide a succinct answer. 61.17. What is the difference between the Gross enrolment ratio (%) in Secondary schools in 2006 and the Gross enrolment ratio (%) in Tertiary schools in 2007?
Your response must be concise. 47.11. What is the difference between the Gross enrolment ratio (%) in Pre-primary schools in 2006 and the Gross enrolment ratio (%) in Primary schools in 2008?
Offer a terse response. -54.72. What is the difference between the Gross enrolment ratio (%) of Pre-primary schools in 2006 and the Gross enrolment ratio (%) of Secondary schools in 2008?
Provide a short and direct response. -43.52. What is the difference between the Gross enrolment ratio (%) in Pre-primary schools in 2006 and the Gross enrolment ratio (%) in Tertiary schools in 2008?
Your answer should be compact. 2.54. What is the difference between the Gross enrolment ratio (%) in Primary schools in 2006 and the Gross enrolment ratio (%) in Secondary schools in 2008?
Your answer should be compact. 14.03. What is the difference between the Gross enrolment ratio (%) in Primary schools in 2006 and the Gross enrolment ratio (%) in Tertiary schools in 2008?
Give a very brief answer. 60.1. What is the difference between the Gross enrolment ratio (%) in Secondary schools in 2006 and the Gross enrolment ratio (%) in Tertiary schools in 2008?
Offer a terse response. 46.03. What is the difference between the Gross enrolment ratio (%) in Pre-primary schools in 2007 and the Gross enrolment ratio (%) in Primary schools in 2008?
Keep it short and to the point. -51.52. What is the difference between the Gross enrolment ratio (%) of Pre-primary schools in 2007 and the Gross enrolment ratio (%) of Secondary schools in 2008?
Offer a very short reply. -40.32. What is the difference between the Gross enrolment ratio (%) of Pre-primary schools in 2007 and the Gross enrolment ratio (%) of Tertiary schools in 2008?
Give a very brief answer. 5.74. What is the difference between the Gross enrolment ratio (%) of Primary schools in 2007 and the Gross enrolment ratio (%) of Secondary schools in 2008?
Provide a succinct answer. 14.55. What is the difference between the Gross enrolment ratio (%) of Primary schools in 2007 and the Gross enrolment ratio (%) of Tertiary schools in 2008?
Ensure brevity in your answer.  60.62. What is the difference between the Gross enrolment ratio (%) in Secondary schools in 2007 and the Gross enrolment ratio (%) in Tertiary schools in 2008?
Offer a very short reply. 45.55. What is the average Gross enrolment ratio (%) of Pre-primary schools per year?
Offer a terse response. 31.04. What is the average Gross enrolment ratio (%) in Primary schools per year?
Ensure brevity in your answer.  92.64. What is the average Gross enrolment ratio (%) of Secondary schools per year?
Your answer should be compact. 79.65. What is the average Gross enrolment ratio (%) of Tertiary schools per year?
Keep it short and to the point. 26.61. In the year 2000, what is the difference between the Gross enrolment ratio (%) in Pre-primary schools and Gross enrolment ratio (%) in Primary schools?
Offer a very short reply. -66.67. In the year 2000, what is the difference between the Gross enrolment ratio (%) in Pre-primary schools and Gross enrolment ratio (%) in Secondary schools?
Your response must be concise. -52.88. In the year 2000, what is the difference between the Gross enrolment ratio (%) in Pre-primary schools and Gross enrolment ratio (%) in Tertiary schools?
Your response must be concise. 7.55. In the year 2000, what is the difference between the Gross enrolment ratio (%) of Primary schools and Gross enrolment ratio (%) of Secondary schools?
Provide a short and direct response. 13.8. In the year 2000, what is the difference between the Gross enrolment ratio (%) of Primary schools and Gross enrolment ratio (%) of Tertiary schools?
Your answer should be very brief. 74.23. In the year 2000, what is the difference between the Gross enrolment ratio (%) in Secondary schools and Gross enrolment ratio (%) in Tertiary schools?
Give a very brief answer. 60.43. In the year 2001, what is the difference between the Gross enrolment ratio (%) in Pre-primary schools and Gross enrolment ratio (%) in Primary schools?
Ensure brevity in your answer.  -64.38. In the year 2001, what is the difference between the Gross enrolment ratio (%) in Pre-primary schools and Gross enrolment ratio (%) in Secondary schools?
Provide a succinct answer. -52.33. In the year 2001, what is the difference between the Gross enrolment ratio (%) in Pre-primary schools and Gross enrolment ratio (%) in Tertiary schools?
Provide a succinct answer. 7.11. In the year 2001, what is the difference between the Gross enrolment ratio (%) of Primary schools and Gross enrolment ratio (%) of Secondary schools?
Offer a terse response. 12.05. In the year 2001, what is the difference between the Gross enrolment ratio (%) of Primary schools and Gross enrolment ratio (%) of Tertiary schools?
Provide a succinct answer. 71.49. In the year 2001, what is the difference between the Gross enrolment ratio (%) of Secondary schools and Gross enrolment ratio (%) of Tertiary schools?
Keep it short and to the point. 59.44. In the year 2002, what is the difference between the Gross enrolment ratio (%) of Pre-primary schools and Gross enrolment ratio (%) of Primary schools?
Your response must be concise. -63.91. In the year 2002, what is the difference between the Gross enrolment ratio (%) in Pre-primary schools and Gross enrolment ratio (%) in Secondary schools?
Provide a succinct answer. -50.72. In the year 2002, what is the difference between the Gross enrolment ratio (%) of Pre-primary schools and Gross enrolment ratio (%) of Tertiary schools?
Give a very brief answer. 6.62. In the year 2002, what is the difference between the Gross enrolment ratio (%) of Primary schools and Gross enrolment ratio (%) of Secondary schools?
Give a very brief answer. 13.19. In the year 2002, what is the difference between the Gross enrolment ratio (%) of Primary schools and Gross enrolment ratio (%) of Tertiary schools?
Your response must be concise. 70.53. In the year 2002, what is the difference between the Gross enrolment ratio (%) in Secondary schools and Gross enrolment ratio (%) in Tertiary schools?
Ensure brevity in your answer.  57.34. In the year 2003, what is the difference between the Gross enrolment ratio (%) in Pre-primary schools and Gross enrolment ratio (%) in Primary schools?
Keep it short and to the point. -60.42. In the year 2003, what is the difference between the Gross enrolment ratio (%) in Pre-primary schools and Gross enrolment ratio (%) in Secondary schools?
Keep it short and to the point. -49.28. In the year 2003, what is the difference between the Gross enrolment ratio (%) in Pre-primary schools and Gross enrolment ratio (%) in Tertiary schools?
Your response must be concise. 6. In the year 2003, what is the difference between the Gross enrolment ratio (%) of Primary schools and Gross enrolment ratio (%) of Secondary schools?
Provide a succinct answer. 11.14. In the year 2003, what is the difference between the Gross enrolment ratio (%) of Primary schools and Gross enrolment ratio (%) of Tertiary schools?
Your answer should be very brief. 66.42. In the year 2003, what is the difference between the Gross enrolment ratio (%) in Secondary schools and Gross enrolment ratio (%) in Tertiary schools?
Your answer should be compact. 55.28. In the year 2004, what is the difference between the Gross enrolment ratio (%) in Pre-primary schools and Gross enrolment ratio (%) in Primary schools?
Make the answer very short. -59.4. In the year 2004, what is the difference between the Gross enrolment ratio (%) in Pre-primary schools and Gross enrolment ratio (%) in Secondary schools?
Make the answer very short. -46.94. In the year 2004, what is the difference between the Gross enrolment ratio (%) in Pre-primary schools and Gross enrolment ratio (%) in Tertiary schools?
Offer a terse response. 6.47. In the year 2004, what is the difference between the Gross enrolment ratio (%) of Primary schools and Gross enrolment ratio (%) of Secondary schools?
Offer a very short reply. 12.46. In the year 2004, what is the difference between the Gross enrolment ratio (%) in Primary schools and Gross enrolment ratio (%) in Tertiary schools?
Offer a terse response. 65.87. In the year 2004, what is the difference between the Gross enrolment ratio (%) in Secondary schools and Gross enrolment ratio (%) in Tertiary schools?
Make the answer very short. 53.41. In the year 2005, what is the difference between the Gross enrolment ratio (%) of Pre-primary schools and Gross enrolment ratio (%) of Primary schools?
Offer a very short reply. -59.48. In the year 2005, what is the difference between the Gross enrolment ratio (%) in Pre-primary schools and Gross enrolment ratio (%) in Secondary schools?
Your answer should be compact. -45.56. In the year 2005, what is the difference between the Gross enrolment ratio (%) of Pre-primary schools and Gross enrolment ratio (%) of Tertiary schools?
Give a very brief answer. 5.15. In the year 2005, what is the difference between the Gross enrolment ratio (%) in Primary schools and Gross enrolment ratio (%) in Secondary schools?
Provide a short and direct response. 13.92. In the year 2005, what is the difference between the Gross enrolment ratio (%) in Primary schools and Gross enrolment ratio (%) in Tertiary schools?
Ensure brevity in your answer.  64.63. In the year 2005, what is the difference between the Gross enrolment ratio (%) of Secondary schools and Gross enrolment ratio (%) of Tertiary schools?
Ensure brevity in your answer.  50.71. In the year 2006, what is the difference between the Gross enrolment ratio (%) of Pre-primary schools and Gross enrolment ratio (%) of Primary schools?
Your answer should be compact. -57.55. In the year 2006, what is the difference between the Gross enrolment ratio (%) of Pre-primary schools and Gross enrolment ratio (%) of Secondary schools?
Ensure brevity in your answer.  -43.49. In the year 2006, what is the difference between the Gross enrolment ratio (%) in Pre-primary schools and Gross enrolment ratio (%) in Tertiary schools?
Give a very brief answer. 4.55. In the year 2006, what is the difference between the Gross enrolment ratio (%) of Primary schools and Gross enrolment ratio (%) of Secondary schools?
Your answer should be very brief. 14.06. In the year 2006, what is the difference between the Gross enrolment ratio (%) in Primary schools and Gross enrolment ratio (%) in Tertiary schools?
Ensure brevity in your answer.  62.1. In the year 2006, what is the difference between the Gross enrolment ratio (%) in Secondary schools and Gross enrolment ratio (%) in Tertiary schools?
Provide a succinct answer. 48.04. In the year 2007, what is the difference between the Gross enrolment ratio (%) of Pre-primary schools and Gross enrolment ratio (%) of Primary schools?
Give a very brief answer. -54.87. In the year 2007, what is the difference between the Gross enrolment ratio (%) of Pre-primary schools and Gross enrolment ratio (%) of Secondary schools?
Give a very brief answer. -39.8. In the year 2007, what is the difference between the Gross enrolment ratio (%) in Pre-primary schools and Gross enrolment ratio (%) in Tertiary schools?
Your answer should be compact. 6.82. In the year 2007, what is the difference between the Gross enrolment ratio (%) of Primary schools and Gross enrolment ratio (%) of Secondary schools?
Your answer should be very brief. 15.07. In the year 2007, what is the difference between the Gross enrolment ratio (%) of Primary schools and Gross enrolment ratio (%) of Tertiary schools?
Give a very brief answer. 61.69. In the year 2007, what is the difference between the Gross enrolment ratio (%) in Secondary schools and Gross enrolment ratio (%) in Tertiary schools?
Give a very brief answer. 46.63. In the year 2008, what is the difference between the Gross enrolment ratio (%) in Pre-primary schools and Gross enrolment ratio (%) in Primary schools?
Provide a short and direct response. -67.7. In the year 2008, what is the difference between the Gross enrolment ratio (%) in Pre-primary schools and Gross enrolment ratio (%) in Secondary schools?
Your response must be concise. -56.5. In the year 2008, what is the difference between the Gross enrolment ratio (%) of Pre-primary schools and Gross enrolment ratio (%) of Tertiary schools?
Your response must be concise. -10.43. In the year 2008, what is the difference between the Gross enrolment ratio (%) in Primary schools and Gross enrolment ratio (%) in Secondary schools?
Your answer should be compact. 11.2. In the year 2008, what is the difference between the Gross enrolment ratio (%) of Primary schools and Gross enrolment ratio (%) of Tertiary schools?
Your answer should be compact. 57.26. In the year 2008, what is the difference between the Gross enrolment ratio (%) of Secondary schools and Gross enrolment ratio (%) of Tertiary schools?
Offer a very short reply. 46.06. What is the ratio of the Gross enrolment ratio (%) of Primary schools in 2000 to that in 2001?
Your answer should be very brief. 1.02. What is the ratio of the Gross enrolment ratio (%) of Tertiary schools in 2000 to that in 2001?
Offer a terse response. 0.97. What is the ratio of the Gross enrolment ratio (%) in Pre-primary schools in 2000 to that in 2002?
Offer a very short reply. 0.98. What is the ratio of the Gross enrolment ratio (%) in Primary schools in 2000 to that in 2002?
Offer a terse response. 1.02. What is the ratio of the Gross enrolment ratio (%) of Secondary schools in 2000 to that in 2002?
Offer a very short reply. 1.02. What is the ratio of the Gross enrolment ratio (%) of Tertiary schools in 2000 to that in 2002?
Your response must be concise. 0.93. What is the ratio of the Gross enrolment ratio (%) of Pre-primary schools in 2000 to that in 2003?
Offer a terse response. 0.93. What is the ratio of the Gross enrolment ratio (%) in Primary schools in 2000 to that in 2003?
Keep it short and to the point. 1.05. What is the ratio of the Gross enrolment ratio (%) in Secondary schools in 2000 to that in 2003?
Your answer should be very brief. 1.02. What is the ratio of the Gross enrolment ratio (%) in Tertiary schools in 2000 to that in 2003?
Your response must be concise. 0.85. What is the ratio of the Gross enrolment ratio (%) of Pre-primary schools in 2000 to that in 2004?
Your response must be concise. 0.89. What is the ratio of the Gross enrolment ratio (%) in Primary schools in 2000 to that in 2004?
Ensure brevity in your answer.  1.04. What is the ratio of the Gross enrolment ratio (%) of Secondary schools in 2000 to that in 2004?
Ensure brevity in your answer.  1.03. What is the ratio of the Gross enrolment ratio (%) of Tertiary schools in 2000 to that in 2004?
Make the answer very short. 0.82. What is the ratio of the Gross enrolment ratio (%) of Pre-primary schools in 2000 to that in 2005?
Offer a terse response. 0.85. What is the ratio of the Gross enrolment ratio (%) in Primary schools in 2000 to that in 2005?
Your answer should be compact. 1.02. What is the ratio of the Gross enrolment ratio (%) of Secondary schools in 2000 to that in 2005?
Ensure brevity in your answer.  1.03. What is the ratio of the Gross enrolment ratio (%) in Tertiary schools in 2000 to that in 2005?
Provide a succinct answer. 0.74. What is the ratio of the Gross enrolment ratio (%) of Pre-primary schools in 2000 to that in 2006?
Your answer should be very brief. 0.81. What is the ratio of the Gross enrolment ratio (%) of Primary schools in 2000 to that in 2006?
Keep it short and to the point. 1.02. What is the ratio of the Gross enrolment ratio (%) of Secondary schools in 2000 to that in 2006?
Your answer should be compact. 1.03. What is the ratio of the Gross enrolment ratio (%) in Tertiary schools in 2000 to that in 2006?
Your response must be concise. 0.68. What is the ratio of the Gross enrolment ratio (%) of Pre-primary schools in 2000 to that in 2007?
Offer a very short reply. 0.74. What is the ratio of the Gross enrolment ratio (%) in Primary schools in 2000 to that in 2007?
Your response must be concise. 1.02. What is the ratio of the Gross enrolment ratio (%) in Secondary schools in 2000 to that in 2007?
Provide a short and direct response. 1.04. What is the ratio of the Gross enrolment ratio (%) in Tertiary schools in 2000 to that in 2007?
Offer a very short reply. 0.66. What is the ratio of the Gross enrolment ratio (%) in Pre-primary schools in 2000 to that in 2008?
Keep it short and to the point. 1.27. What is the ratio of the Gross enrolment ratio (%) of Primary schools in 2000 to that in 2008?
Keep it short and to the point. 1.06. What is the ratio of the Gross enrolment ratio (%) of Secondary schools in 2000 to that in 2008?
Ensure brevity in your answer.  1.03. What is the ratio of the Gross enrolment ratio (%) in Tertiary schools in 2000 to that in 2008?
Make the answer very short. 0.64. What is the ratio of the Gross enrolment ratio (%) of Pre-primary schools in 2001 to that in 2002?
Keep it short and to the point. 0.99. What is the ratio of the Gross enrolment ratio (%) in Secondary schools in 2001 to that in 2002?
Give a very brief answer. 1.02. What is the ratio of the Gross enrolment ratio (%) in Tertiary schools in 2001 to that in 2002?
Provide a short and direct response. 0.97. What is the ratio of the Gross enrolment ratio (%) in Pre-primary schools in 2001 to that in 2003?
Your response must be concise. 0.94. What is the ratio of the Gross enrolment ratio (%) in Primary schools in 2001 to that in 2003?
Provide a short and direct response. 1.02. What is the ratio of the Gross enrolment ratio (%) in Secondary schools in 2001 to that in 2003?
Keep it short and to the point. 1.02. What is the ratio of the Gross enrolment ratio (%) in Tertiary schools in 2001 to that in 2003?
Offer a terse response. 0.88. What is the ratio of the Gross enrolment ratio (%) of Pre-primary schools in 2001 to that in 2004?
Provide a short and direct response. 0.9. What is the ratio of the Gross enrolment ratio (%) in Primary schools in 2001 to that in 2004?
Make the answer very short. 1.02. What is the ratio of the Gross enrolment ratio (%) in Secondary schools in 2001 to that in 2004?
Provide a short and direct response. 1.03. What is the ratio of the Gross enrolment ratio (%) in Tertiary schools in 2001 to that in 2004?
Your response must be concise. 0.84. What is the ratio of the Gross enrolment ratio (%) in Pre-primary schools in 2001 to that in 2005?
Ensure brevity in your answer.  0.86. What is the ratio of the Gross enrolment ratio (%) of Primary schools in 2001 to that in 2005?
Your answer should be compact. 1. What is the ratio of the Gross enrolment ratio (%) in Secondary schools in 2001 to that in 2005?
Make the answer very short. 1.03. What is the ratio of the Gross enrolment ratio (%) in Tertiary schools in 2001 to that in 2005?
Your answer should be compact. 0.77. What is the ratio of the Gross enrolment ratio (%) in Pre-primary schools in 2001 to that in 2006?
Provide a short and direct response. 0.82. What is the ratio of the Gross enrolment ratio (%) in Secondary schools in 2001 to that in 2006?
Give a very brief answer. 1.03. What is the ratio of the Gross enrolment ratio (%) of Tertiary schools in 2001 to that in 2006?
Provide a short and direct response. 0.71. What is the ratio of the Gross enrolment ratio (%) of Pre-primary schools in 2001 to that in 2007?
Offer a very short reply. 0.75. What is the ratio of the Gross enrolment ratio (%) of Secondary schools in 2001 to that in 2007?
Your response must be concise. 1.04. What is the ratio of the Gross enrolment ratio (%) in Tertiary schools in 2001 to that in 2007?
Ensure brevity in your answer.  0.68. What is the ratio of the Gross enrolment ratio (%) of Pre-primary schools in 2001 to that in 2008?
Offer a very short reply. 1.29. What is the ratio of the Gross enrolment ratio (%) of Primary schools in 2001 to that in 2008?
Offer a very short reply. 1.03. What is the ratio of the Gross enrolment ratio (%) of Secondary schools in 2001 to that in 2008?
Make the answer very short. 1.03. What is the ratio of the Gross enrolment ratio (%) in Tertiary schools in 2001 to that in 2008?
Offer a very short reply. 0.66. What is the ratio of the Gross enrolment ratio (%) in Pre-primary schools in 2002 to that in 2003?
Your response must be concise. 0.95. What is the ratio of the Gross enrolment ratio (%) in Tertiary schools in 2002 to that in 2003?
Give a very brief answer. 0.91. What is the ratio of the Gross enrolment ratio (%) in Pre-primary schools in 2002 to that in 2004?
Provide a succinct answer. 0.9. What is the ratio of the Gross enrolment ratio (%) of Primary schools in 2002 to that in 2004?
Offer a terse response. 1.02. What is the ratio of the Gross enrolment ratio (%) of Secondary schools in 2002 to that in 2004?
Offer a very short reply. 1.01. What is the ratio of the Gross enrolment ratio (%) of Tertiary schools in 2002 to that in 2004?
Keep it short and to the point. 0.87. What is the ratio of the Gross enrolment ratio (%) in Pre-primary schools in 2002 to that in 2005?
Keep it short and to the point. 0.87. What is the ratio of the Gross enrolment ratio (%) in Secondary schools in 2002 to that in 2005?
Ensure brevity in your answer.  1.01. What is the ratio of the Gross enrolment ratio (%) in Tertiary schools in 2002 to that in 2005?
Make the answer very short. 0.79. What is the ratio of the Gross enrolment ratio (%) of Pre-primary schools in 2002 to that in 2006?
Offer a very short reply. 0.82. What is the ratio of the Gross enrolment ratio (%) in Secondary schools in 2002 to that in 2006?
Ensure brevity in your answer.  1.01. What is the ratio of the Gross enrolment ratio (%) of Tertiary schools in 2002 to that in 2006?
Ensure brevity in your answer.  0.73. What is the ratio of the Gross enrolment ratio (%) of Pre-primary schools in 2002 to that in 2007?
Keep it short and to the point. 0.75. What is the ratio of the Gross enrolment ratio (%) in Primary schools in 2002 to that in 2007?
Provide a succinct answer. 1. What is the ratio of the Gross enrolment ratio (%) of Secondary schools in 2002 to that in 2007?
Offer a terse response. 1.02. What is the ratio of the Gross enrolment ratio (%) of Tertiary schools in 2002 to that in 2007?
Your answer should be very brief. 0.71. What is the ratio of the Gross enrolment ratio (%) in Pre-primary schools in 2002 to that in 2008?
Your answer should be very brief. 1.3. What is the ratio of the Gross enrolment ratio (%) of Primary schools in 2002 to that in 2008?
Your answer should be compact. 1.03. What is the ratio of the Gross enrolment ratio (%) of Secondary schools in 2002 to that in 2008?
Your answer should be very brief. 1.01. What is the ratio of the Gross enrolment ratio (%) of Tertiary schools in 2002 to that in 2008?
Provide a succinct answer. 0.69. What is the ratio of the Gross enrolment ratio (%) of Pre-primary schools in 2003 to that in 2004?
Offer a very short reply. 0.95. What is the ratio of the Gross enrolment ratio (%) of Primary schools in 2003 to that in 2004?
Keep it short and to the point. 0.99. What is the ratio of the Gross enrolment ratio (%) of Secondary schools in 2003 to that in 2004?
Offer a terse response. 1.01. What is the ratio of the Gross enrolment ratio (%) in Tertiary schools in 2003 to that in 2004?
Make the answer very short. 0.96. What is the ratio of the Gross enrolment ratio (%) of Pre-primary schools in 2003 to that in 2005?
Offer a very short reply. 0.92. What is the ratio of the Gross enrolment ratio (%) in Primary schools in 2003 to that in 2005?
Your answer should be very brief. 0.98. What is the ratio of the Gross enrolment ratio (%) in Secondary schools in 2003 to that in 2005?
Offer a very short reply. 1.01. What is the ratio of the Gross enrolment ratio (%) in Tertiary schools in 2003 to that in 2005?
Provide a succinct answer. 0.87. What is the ratio of the Gross enrolment ratio (%) in Pre-primary schools in 2003 to that in 2006?
Offer a very short reply. 0.87. What is the ratio of the Gross enrolment ratio (%) in Primary schools in 2003 to that in 2006?
Offer a terse response. 0.98. What is the ratio of the Gross enrolment ratio (%) in Secondary schools in 2003 to that in 2006?
Give a very brief answer. 1.01. What is the ratio of the Gross enrolment ratio (%) in Tertiary schools in 2003 to that in 2006?
Offer a very short reply. 0.8. What is the ratio of the Gross enrolment ratio (%) of Pre-primary schools in 2003 to that in 2007?
Give a very brief answer. 0.8. What is the ratio of the Gross enrolment ratio (%) of Primary schools in 2003 to that in 2007?
Your answer should be very brief. 0.97. What is the ratio of the Gross enrolment ratio (%) in Secondary schools in 2003 to that in 2007?
Provide a succinct answer. 1.02. What is the ratio of the Gross enrolment ratio (%) of Tertiary schools in 2003 to that in 2007?
Provide a succinct answer. 0.78. What is the ratio of the Gross enrolment ratio (%) in Pre-primary schools in 2003 to that in 2008?
Give a very brief answer. 1.37. What is the ratio of the Gross enrolment ratio (%) in Primary schools in 2003 to that in 2008?
Keep it short and to the point. 1.01. What is the ratio of the Gross enrolment ratio (%) of Secondary schools in 2003 to that in 2008?
Make the answer very short. 1.01. What is the ratio of the Gross enrolment ratio (%) in Tertiary schools in 2003 to that in 2008?
Give a very brief answer. 0.75. What is the ratio of the Gross enrolment ratio (%) in Pre-primary schools in 2004 to that in 2005?
Your answer should be compact. 0.96. What is the ratio of the Gross enrolment ratio (%) in Primary schools in 2004 to that in 2005?
Ensure brevity in your answer.  0.99. What is the ratio of the Gross enrolment ratio (%) of Secondary schools in 2004 to that in 2005?
Offer a very short reply. 1. What is the ratio of the Gross enrolment ratio (%) in Tertiary schools in 2004 to that in 2005?
Your answer should be very brief. 0.91. What is the ratio of the Gross enrolment ratio (%) in Pre-primary schools in 2004 to that in 2006?
Provide a succinct answer. 0.91. What is the ratio of the Gross enrolment ratio (%) in Primary schools in 2004 to that in 2006?
Offer a terse response. 0.99. What is the ratio of the Gross enrolment ratio (%) of Secondary schools in 2004 to that in 2006?
Give a very brief answer. 1. What is the ratio of the Gross enrolment ratio (%) in Tertiary schools in 2004 to that in 2006?
Offer a terse response. 0.84. What is the ratio of the Gross enrolment ratio (%) in Pre-primary schools in 2004 to that in 2007?
Keep it short and to the point. 0.84. What is the ratio of the Gross enrolment ratio (%) of Primary schools in 2004 to that in 2007?
Your answer should be very brief. 0.98. What is the ratio of the Gross enrolment ratio (%) of Tertiary schools in 2004 to that in 2007?
Your answer should be compact. 0.81. What is the ratio of the Gross enrolment ratio (%) in Pre-primary schools in 2004 to that in 2008?
Keep it short and to the point. 1.44. What is the ratio of the Gross enrolment ratio (%) in Secondary schools in 2004 to that in 2008?
Your answer should be very brief. 1. What is the ratio of the Gross enrolment ratio (%) of Tertiary schools in 2004 to that in 2008?
Offer a very short reply. 0.78. What is the ratio of the Gross enrolment ratio (%) in Pre-primary schools in 2005 to that in 2006?
Make the answer very short. 0.95. What is the ratio of the Gross enrolment ratio (%) of Secondary schools in 2005 to that in 2006?
Keep it short and to the point. 1. What is the ratio of the Gross enrolment ratio (%) of Tertiary schools in 2005 to that in 2006?
Ensure brevity in your answer.  0.92. What is the ratio of the Gross enrolment ratio (%) of Pre-primary schools in 2005 to that in 2007?
Give a very brief answer. 0.87. What is the ratio of the Gross enrolment ratio (%) of Primary schools in 2005 to that in 2007?
Provide a short and direct response. 1. What is the ratio of the Gross enrolment ratio (%) of Secondary schools in 2005 to that in 2007?
Your response must be concise. 1.01. What is the ratio of the Gross enrolment ratio (%) in Tertiary schools in 2005 to that in 2007?
Ensure brevity in your answer.  0.89. What is the ratio of the Gross enrolment ratio (%) of Pre-primary schools in 2005 to that in 2008?
Offer a terse response. 1.5. What is the ratio of the Gross enrolment ratio (%) of Primary schools in 2005 to that in 2008?
Provide a short and direct response. 1.03. What is the ratio of the Gross enrolment ratio (%) in Secondary schools in 2005 to that in 2008?
Provide a short and direct response. 1. What is the ratio of the Gross enrolment ratio (%) of Tertiary schools in 2005 to that in 2008?
Offer a very short reply. 0.86. What is the ratio of the Gross enrolment ratio (%) of Pre-primary schools in 2006 to that in 2007?
Your answer should be very brief. 0.92. What is the ratio of the Gross enrolment ratio (%) of Primary schools in 2006 to that in 2007?
Offer a very short reply. 0.99. What is the ratio of the Gross enrolment ratio (%) in Secondary schools in 2006 to that in 2007?
Your response must be concise. 1.01. What is the ratio of the Gross enrolment ratio (%) of Tertiary schools in 2006 to that in 2007?
Ensure brevity in your answer.  0.97. What is the ratio of the Gross enrolment ratio (%) of Pre-primary schools in 2006 to that in 2008?
Offer a terse response. 1.58. What is the ratio of the Gross enrolment ratio (%) in Primary schools in 2006 to that in 2008?
Give a very brief answer. 1.03. What is the ratio of the Gross enrolment ratio (%) in Secondary schools in 2006 to that in 2008?
Your answer should be very brief. 1. What is the ratio of the Gross enrolment ratio (%) in Tertiary schools in 2006 to that in 2008?
Keep it short and to the point. 0.94. What is the ratio of the Gross enrolment ratio (%) of Pre-primary schools in 2007 to that in 2008?
Provide a succinct answer. 1.72. What is the ratio of the Gross enrolment ratio (%) of Primary schools in 2007 to that in 2008?
Provide a short and direct response. 1.04. What is the ratio of the Gross enrolment ratio (%) in Secondary schools in 2007 to that in 2008?
Your answer should be very brief. 0.99. What is the ratio of the Gross enrolment ratio (%) in Tertiary schools in 2007 to that in 2008?
Provide a succinct answer. 0.97. What is the difference between the highest and the second highest Gross enrolment ratio (%) in Pre-primary schools?
Your answer should be very brief. 3.2. What is the difference between the highest and the second highest Gross enrolment ratio (%) in Primary schools?
Make the answer very short. 1.77. What is the difference between the highest and the second highest Gross enrolment ratio (%) of Secondary schools?
Your answer should be compact. 0.25. What is the difference between the highest and the second highest Gross enrolment ratio (%) in Tertiary schools?
Make the answer very short. 1.08. What is the difference between the highest and the lowest Gross enrolment ratio (%) of Pre-primary schools?
Offer a very short reply. 16.18. What is the difference between the highest and the lowest Gross enrolment ratio (%) of Primary schools?
Keep it short and to the point. 5.13. What is the difference between the highest and the lowest Gross enrolment ratio (%) in Secondary schools?
Your answer should be very brief. 3.04. What is the difference between the highest and the lowest Gross enrolment ratio (%) of Tertiary schools?
Offer a very short reply. 11.84. 